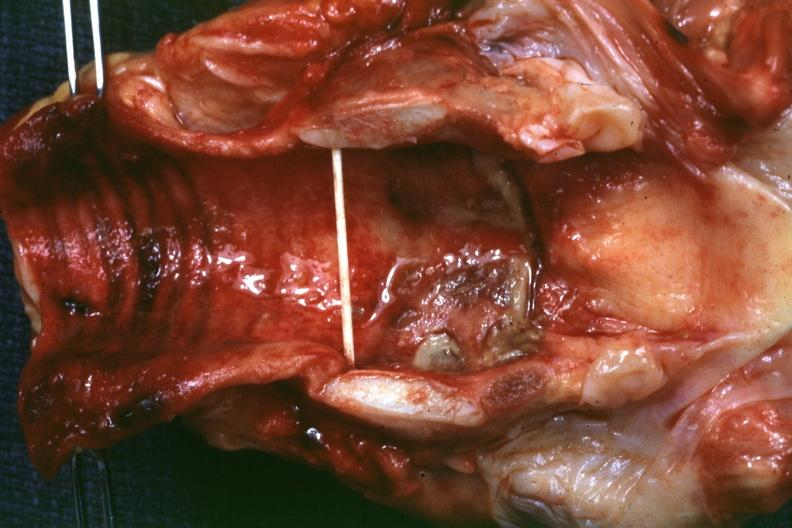what is present?
Answer the question using a single word or phrase. Larynx 